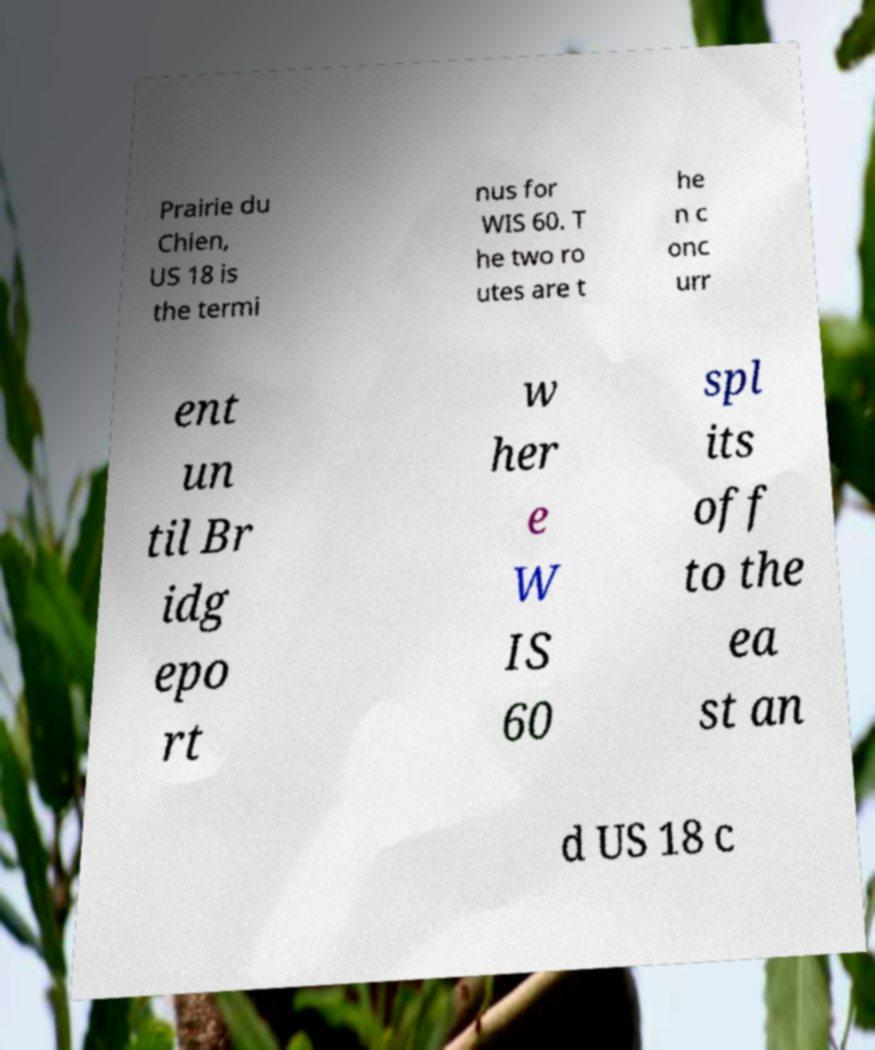Can you accurately transcribe the text from the provided image for me? Prairie du Chien, US 18 is the termi nus for WIS 60. T he two ro utes are t he n c onc urr ent un til Br idg epo rt w her e W IS 60 spl its off to the ea st an d US 18 c 